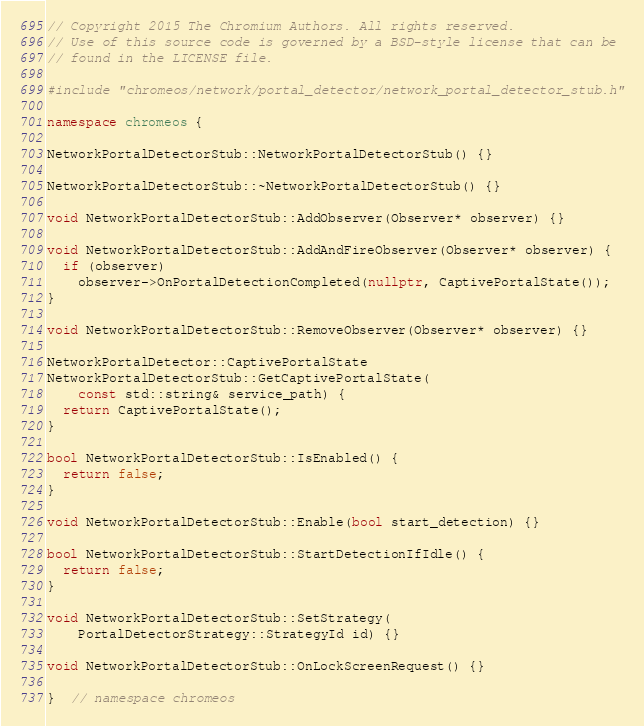Convert code to text. <code><loc_0><loc_0><loc_500><loc_500><_C++_>// Copyright 2015 The Chromium Authors. All rights reserved.
// Use of this source code is governed by a BSD-style license that can be
// found in the LICENSE file.

#include "chromeos/network/portal_detector/network_portal_detector_stub.h"

namespace chromeos {

NetworkPortalDetectorStub::NetworkPortalDetectorStub() {}

NetworkPortalDetectorStub::~NetworkPortalDetectorStub() {}

void NetworkPortalDetectorStub::AddObserver(Observer* observer) {}

void NetworkPortalDetectorStub::AddAndFireObserver(Observer* observer) {
  if (observer)
    observer->OnPortalDetectionCompleted(nullptr, CaptivePortalState());
}

void NetworkPortalDetectorStub::RemoveObserver(Observer* observer) {}

NetworkPortalDetector::CaptivePortalState
NetworkPortalDetectorStub::GetCaptivePortalState(
    const std::string& service_path) {
  return CaptivePortalState();
}

bool NetworkPortalDetectorStub::IsEnabled() {
  return false;
}

void NetworkPortalDetectorStub::Enable(bool start_detection) {}

bool NetworkPortalDetectorStub::StartDetectionIfIdle() {
  return false;
}

void NetworkPortalDetectorStub::SetStrategy(
    PortalDetectorStrategy::StrategyId id) {}

void NetworkPortalDetectorStub::OnLockScreenRequest() {}

}  // namespace chromeos
</code> 